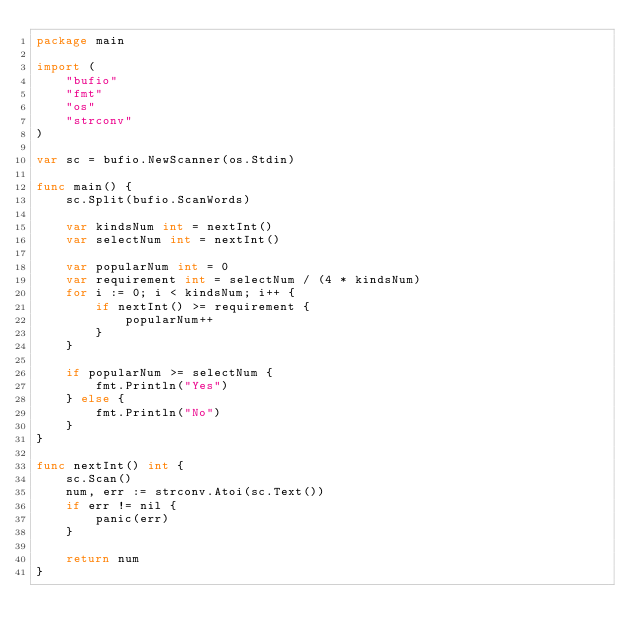<code> <loc_0><loc_0><loc_500><loc_500><_Go_>package main

import (
	"bufio"
	"fmt"
	"os"
	"strconv"
)

var sc = bufio.NewScanner(os.Stdin)

func main() {
	sc.Split(bufio.ScanWords)

	var kindsNum int = nextInt()
	var selectNum int = nextInt()

	var popularNum int = 0
	var requirement int = selectNum / (4 * kindsNum)
	for i := 0; i < kindsNum; i++ {
		if nextInt() >= requirement {
			popularNum++
		}
	}

	if popularNum >= selectNum {
		fmt.Println("Yes")
	} else {
		fmt.Println("No")
	}
}

func nextInt() int {
	sc.Scan()
	num, err := strconv.Atoi(sc.Text())
	if err != nil {
		panic(err)
	}

	return num
}
</code> 